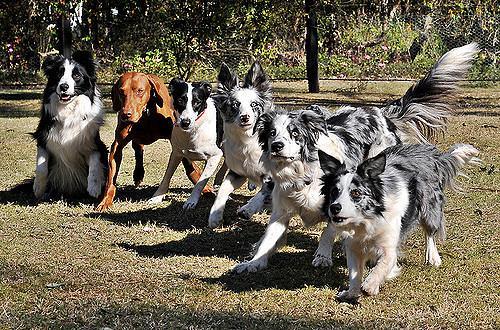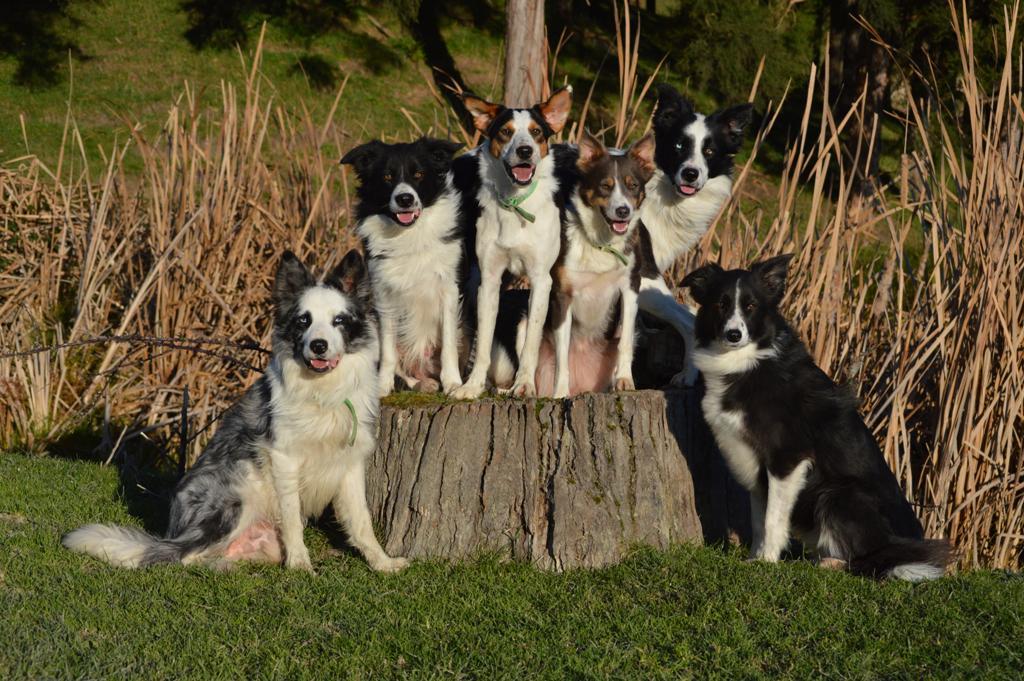The first image is the image on the left, the second image is the image on the right. Examine the images to the left and right. Is the description "There are at least three dogs with white fur elevated above another row of dogs who are sitting or laying down." accurate? Answer yes or no. Yes. The first image is the image on the left, the second image is the image on the right. Considering the images on both sides, is "There is a brown hound dog in the image on the left." valid? Answer yes or no. Yes. 